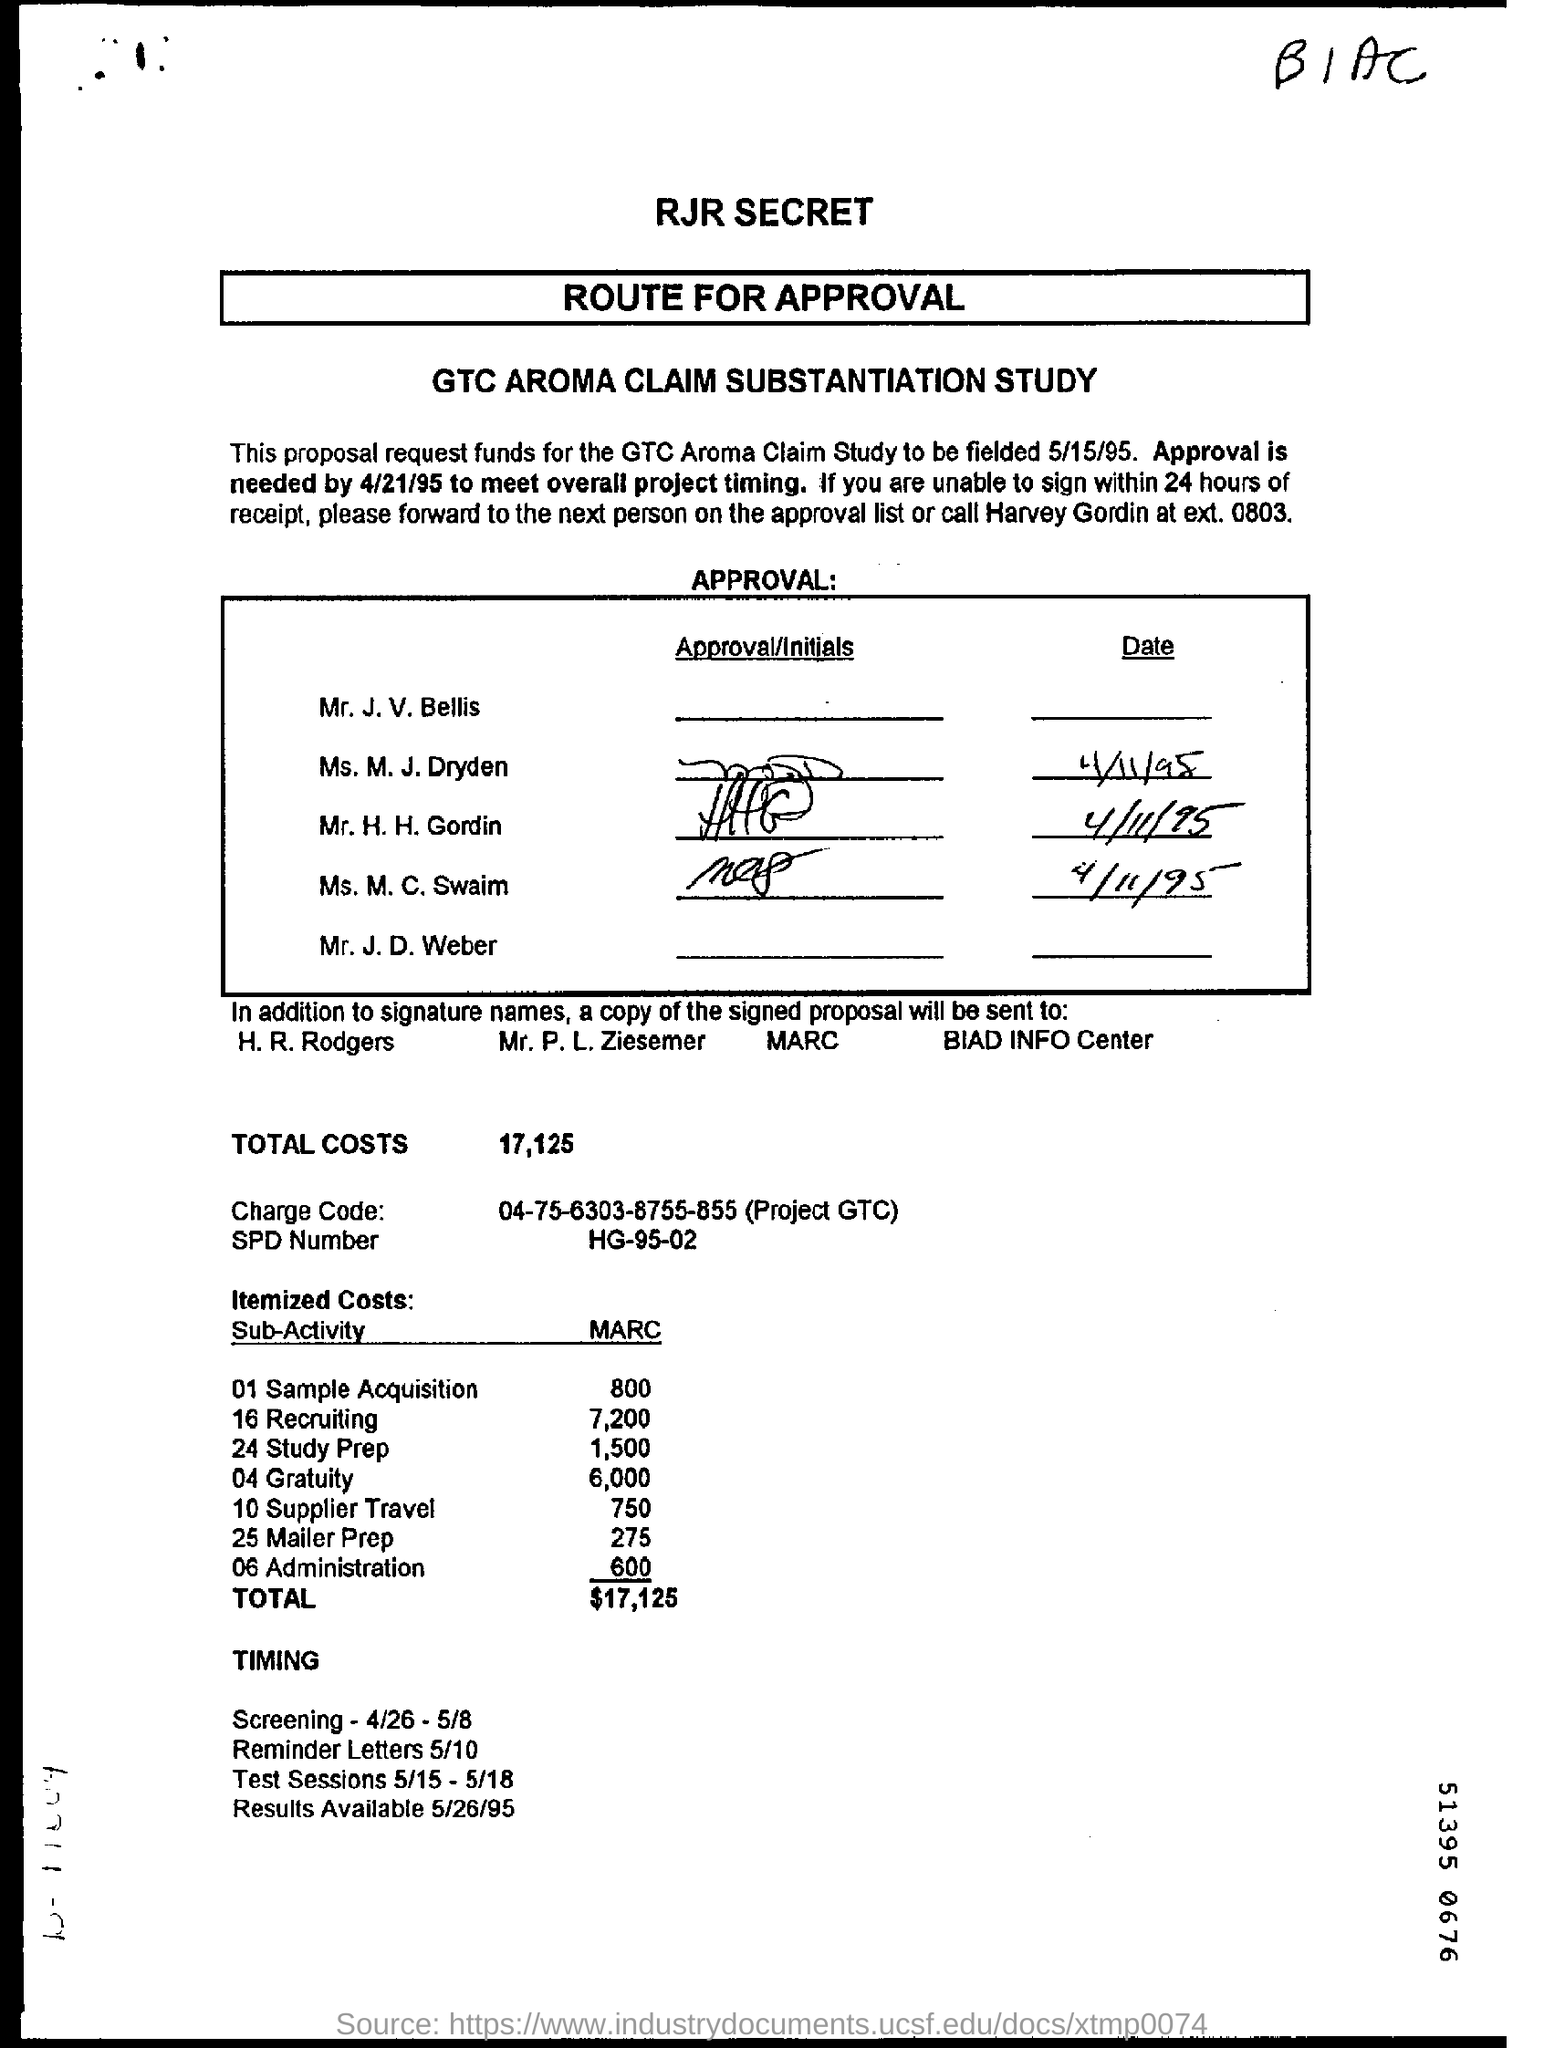What is the name of the study?
Offer a very short reply. GTC AROMA CLAIM SUBSTANTIATION STUDY. When is the GTC Aroma Claim Study to be fielded?
Offer a terse response. 5/15/95. When is the approval needed in order to meet overall project timing?
Offer a very short reply. 4/21/95. What is the SPD Number?
Keep it short and to the point. HG-95-02. 